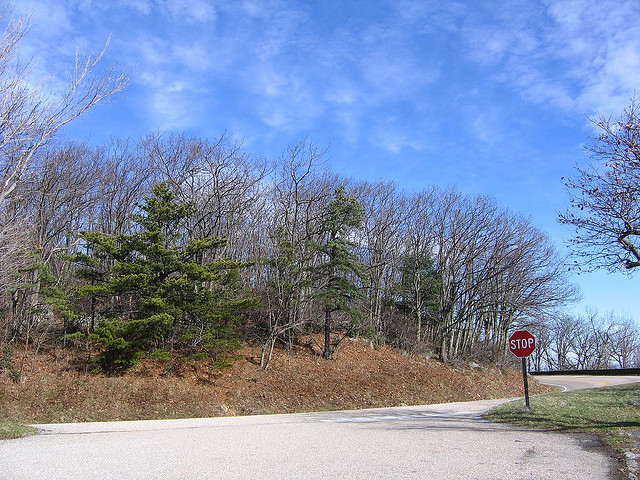What color is the grass? The grass in the image is a vibrant green, typical of well-watered grasslands. 